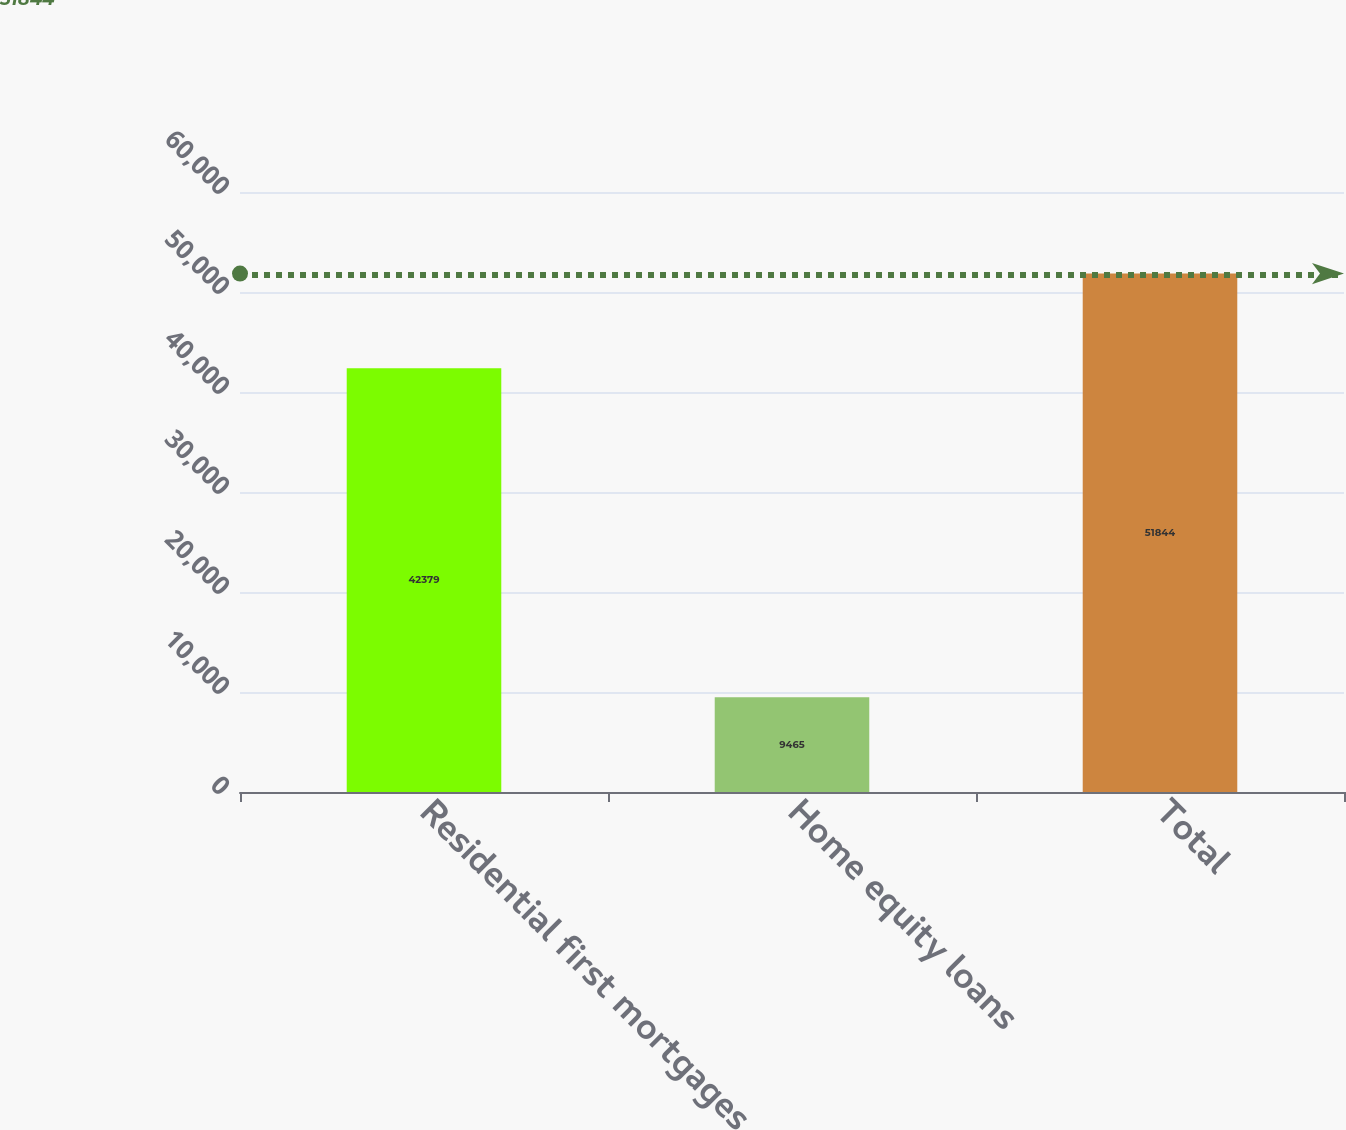<chart> <loc_0><loc_0><loc_500><loc_500><bar_chart><fcel>Residential first mortgages<fcel>Home equity loans<fcel>Total<nl><fcel>42379<fcel>9465<fcel>51844<nl></chart> 